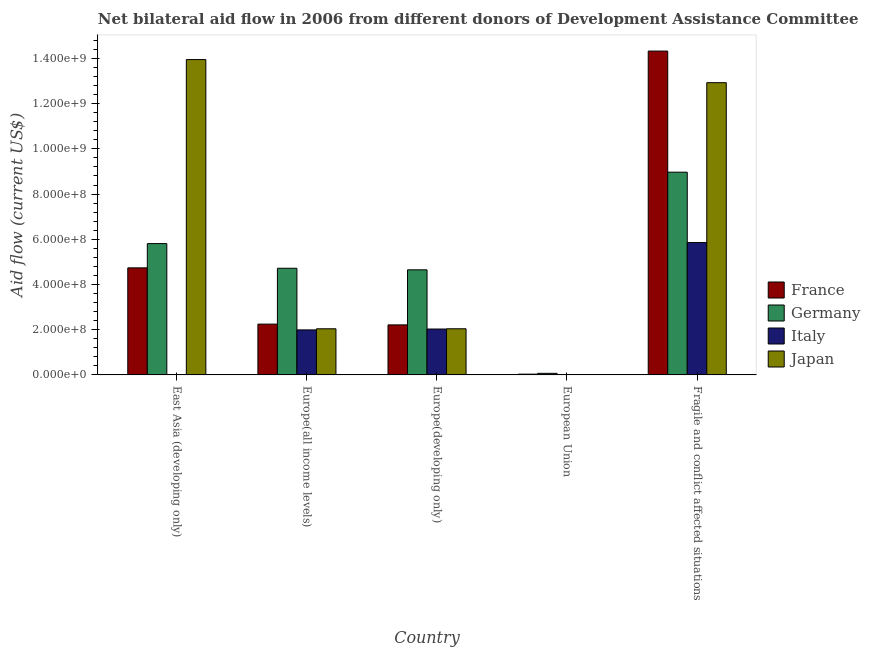How many different coloured bars are there?
Offer a very short reply. 4. How many groups of bars are there?
Offer a terse response. 5. How many bars are there on the 3rd tick from the right?
Provide a succinct answer. 4. What is the label of the 2nd group of bars from the left?
Your response must be concise. Europe(all income levels). In how many cases, is the number of bars for a given country not equal to the number of legend labels?
Offer a very short reply. 2. What is the amount of aid given by italy in Europe(all income levels)?
Keep it short and to the point. 1.99e+08. Across all countries, what is the maximum amount of aid given by germany?
Ensure brevity in your answer.  8.97e+08. Across all countries, what is the minimum amount of aid given by japan?
Offer a very short reply. 0. In which country was the amount of aid given by japan maximum?
Offer a very short reply. East Asia (developing only). What is the total amount of aid given by italy in the graph?
Give a very brief answer. 9.87e+08. What is the difference between the amount of aid given by japan in East Asia (developing only) and that in Europe(all income levels)?
Ensure brevity in your answer.  1.19e+09. What is the difference between the amount of aid given by italy in Europe(all income levels) and the amount of aid given by germany in Fragile and conflict affected situations?
Your response must be concise. -6.98e+08. What is the average amount of aid given by france per country?
Ensure brevity in your answer.  4.71e+08. What is the difference between the amount of aid given by france and amount of aid given by italy in Europe(all income levels)?
Keep it short and to the point. 2.56e+07. In how many countries, is the amount of aid given by france greater than 960000000 US$?
Keep it short and to the point. 1. What is the ratio of the amount of aid given by japan in East Asia (developing only) to that in Europe(developing only)?
Ensure brevity in your answer.  6.83. Is the amount of aid given by germany in East Asia (developing only) less than that in Europe(all income levels)?
Your answer should be very brief. No. What is the difference between the highest and the second highest amount of aid given by germany?
Keep it short and to the point. 3.16e+08. What is the difference between the highest and the lowest amount of aid given by japan?
Give a very brief answer. 1.39e+09. In how many countries, is the amount of aid given by germany greater than the average amount of aid given by germany taken over all countries?
Provide a succinct answer. 2. Is the sum of the amount of aid given by france in East Asia (developing only) and Fragile and conflict affected situations greater than the maximum amount of aid given by italy across all countries?
Give a very brief answer. Yes. Is it the case that in every country, the sum of the amount of aid given by germany and amount of aid given by japan is greater than the sum of amount of aid given by italy and amount of aid given by france?
Offer a very short reply. No. Is it the case that in every country, the sum of the amount of aid given by france and amount of aid given by germany is greater than the amount of aid given by italy?
Keep it short and to the point. Yes. How many bars are there?
Offer a very short reply. 17. What is the difference between two consecutive major ticks on the Y-axis?
Provide a succinct answer. 2.00e+08. Does the graph contain grids?
Offer a terse response. No. Where does the legend appear in the graph?
Provide a short and direct response. Center right. How are the legend labels stacked?
Ensure brevity in your answer.  Vertical. What is the title of the graph?
Keep it short and to the point. Net bilateral aid flow in 2006 from different donors of Development Assistance Committee. Does "Luxembourg" appear as one of the legend labels in the graph?
Give a very brief answer. No. What is the Aid flow (current US$) in France in East Asia (developing only)?
Provide a succinct answer. 4.74e+08. What is the Aid flow (current US$) of Germany in East Asia (developing only)?
Ensure brevity in your answer.  5.81e+08. What is the Aid flow (current US$) in Italy in East Asia (developing only)?
Your response must be concise. 0. What is the Aid flow (current US$) in Japan in East Asia (developing only)?
Offer a terse response. 1.39e+09. What is the Aid flow (current US$) in France in Europe(all income levels)?
Provide a succinct answer. 2.25e+08. What is the Aid flow (current US$) in Germany in Europe(all income levels)?
Keep it short and to the point. 4.72e+08. What is the Aid flow (current US$) of Italy in Europe(all income levels)?
Offer a very short reply. 1.99e+08. What is the Aid flow (current US$) of Japan in Europe(all income levels)?
Offer a very short reply. 2.04e+08. What is the Aid flow (current US$) of France in Europe(developing only)?
Provide a succinct answer. 2.21e+08. What is the Aid flow (current US$) in Germany in Europe(developing only)?
Provide a short and direct response. 4.65e+08. What is the Aid flow (current US$) in Italy in Europe(developing only)?
Keep it short and to the point. 2.03e+08. What is the Aid flow (current US$) in Japan in Europe(developing only)?
Give a very brief answer. 2.04e+08. What is the Aid flow (current US$) in France in European Union?
Your answer should be compact. 3.39e+06. What is the Aid flow (current US$) of Germany in European Union?
Ensure brevity in your answer.  6.94e+06. What is the Aid flow (current US$) in Japan in European Union?
Provide a short and direct response. 0. What is the Aid flow (current US$) of France in Fragile and conflict affected situations?
Offer a very short reply. 1.43e+09. What is the Aid flow (current US$) of Germany in Fragile and conflict affected situations?
Provide a succinct answer. 8.97e+08. What is the Aid flow (current US$) of Italy in Fragile and conflict affected situations?
Keep it short and to the point. 5.85e+08. What is the Aid flow (current US$) of Japan in Fragile and conflict affected situations?
Offer a terse response. 1.29e+09. Across all countries, what is the maximum Aid flow (current US$) in France?
Your answer should be compact. 1.43e+09. Across all countries, what is the maximum Aid flow (current US$) in Germany?
Your response must be concise. 8.97e+08. Across all countries, what is the maximum Aid flow (current US$) of Italy?
Your answer should be very brief. 5.85e+08. Across all countries, what is the maximum Aid flow (current US$) of Japan?
Provide a short and direct response. 1.39e+09. Across all countries, what is the minimum Aid flow (current US$) of France?
Offer a terse response. 3.39e+06. Across all countries, what is the minimum Aid flow (current US$) of Germany?
Offer a terse response. 6.94e+06. Across all countries, what is the minimum Aid flow (current US$) in Italy?
Your answer should be very brief. 0. What is the total Aid flow (current US$) in France in the graph?
Your response must be concise. 2.36e+09. What is the total Aid flow (current US$) of Germany in the graph?
Your answer should be compact. 2.42e+09. What is the total Aid flow (current US$) in Italy in the graph?
Provide a short and direct response. 9.87e+08. What is the total Aid flow (current US$) of Japan in the graph?
Offer a very short reply. 3.10e+09. What is the difference between the Aid flow (current US$) of France in East Asia (developing only) and that in Europe(all income levels)?
Provide a succinct answer. 2.49e+08. What is the difference between the Aid flow (current US$) in Germany in East Asia (developing only) and that in Europe(all income levels)?
Give a very brief answer. 1.09e+08. What is the difference between the Aid flow (current US$) in Japan in East Asia (developing only) and that in Europe(all income levels)?
Your answer should be compact. 1.19e+09. What is the difference between the Aid flow (current US$) in France in East Asia (developing only) and that in Europe(developing only)?
Ensure brevity in your answer.  2.52e+08. What is the difference between the Aid flow (current US$) of Germany in East Asia (developing only) and that in Europe(developing only)?
Ensure brevity in your answer.  1.16e+08. What is the difference between the Aid flow (current US$) of Japan in East Asia (developing only) and that in Europe(developing only)?
Offer a terse response. 1.19e+09. What is the difference between the Aid flow (current US$) in France in East Asia (developing only) and that in European Union?
Provide a succinct answer. 4.70e+08. What is the difference between the Aid flow (current US$) of Germany in East Asia (developing only) and that in European Union?
Make the answer very short. 5.74e+08. What is the difference between the Aid flow (current US$) of France in East Asia (developing only) and that in Fragile and conflict affected situations?
Your response must be concise. -9.59e+08. What is the difference between the Aid flow (current US$) of Germany in East Asia (developing only) and that in Fragile and conflict affected situations?
Provide a short and direct response. -3.16e+08. What is the difference between the Aid flow (current US$) of Japan in East Asia (developing only) and that in Fragile and conflict affected situations?
Provide a succinct answer. 1.02e+08. What is the difference between the Aid flow (current US$) in France in Europe(all income levels) and that in Europe(developing only)?
Make the answer very short. 3.39e+06. What is the difference between the Aid flow (current US$) of Germany in Europe(all income levels) and that in Europe(developing only)?
Provide a short and direct response. 6.94e+06. What is the difference between the Aid flow (current US$) in Italy in Europe(all income levels) and that in Europe(developing only)?
Keep it short and to the point. -3.89e+06. What is the difference between the Aid flow (current US$) in France in Europe(all income levels) and that in European Union?
Offer a very short reply. 2.21e+08. What is the difference between the Aid flow (current US$) of Germany in Europe(all income levels) and that in European Union?
Your answer should be compact. 4.65e+08. What is the difference between the Aid flow (current US$) in France in Europe(all income levels) and that in Fragile and conflict affected situations?
Your answer should be very brief. -1.21e+09. What is the difference between the Aid flow (current US$) in Germany in Europe(all income levels) and that in Fragile and conflict affected situations?
Your answer should be compact. -4.25e+08. What is the difference between the Aid flow (current US$) in Italy in Europe(all income levels) and that in Fragile and conflict affected situations?
Provide a succinct answer. -3.86e+08. What is the difference between the Aid flow (current US$) in Japan in Europe(all income levels) and that in Fragile and conflict affected situations?
Provide a short and direct response. -1.09e+09. What is the difference between the Aid flow (current US$) of France in Europe(developing only) and that in European Union?
Your answer should be compact. 2.18e+08. What is the difference between the Aid flow (current US$) of Germany in Europe(developing only) and that in European Union?
Keep it short and to the point. 4.58e+08. What is the difference between the Aid flow (current US$) of France in Europe(developing only) and that in Fragile and conflict affected situations?
Make the answer very short. -1.21e+09. What is the difference between the Aid flow (current US$) in Germany in Europe(developing only) and that in Fragile and conflict affected situations?
Your answer should be very brief. -4.32e+08. What is the difference between the Aid flow (current US$) of Italy in Europe(developing only) and that in Fragile and conflict affected situations?
Give a very brief answer. -3.82e+08. What is the difference between the Aid flow (current US$) in Japan in Europe(developing only) and that in Fragile and conflict affected situations?
Your response must be concise. -1.09e+09. What is the difference between the Aid flow (current US$) of France in European Union and that in Fragile and conflict affected situations?
Keep it short and to the point. -1.43e+09. What is the difference between the Aid flow (current US$) in Germany in European Union and that in Fragile and conflict affected situations?
Ensure brevity in your answer.  -8.90e+08. What is the difference between the Aid flow (current US$) in France in East Asia (developing only) and the Aid flow (current US$) in Germany in Europe(all income levels)?
Provide a short and direct response. 1.77e+06. What is the difference between the Aid flow (current US$) in France in East Asia (developing only) and the Aid flow (current US$) in Italy in Europe(all income levels)?
Give a very brief answer. 2.74e+08. What is the difference between the Aid flow (current US$) of France in East Asia (developing only) and the Aid flow (current US$) of Japan in Europe(all income levels)?
Give a very brief answer. 2.70e+08. What is the difference between the Aid flow (current US$) of Germany in East Asia (developing only) and the Aid flow (current US$) of Italy in Europe(all income levels)?
Your response must be concise. 3.82e+08. What is the difference between the Aid flow (current US$) in Germany in East Asia (developing only) and the Aid flow (current US$) in Japan in Europe(all income levels)?
Provide a succinct answer. 3.77e+08. What is the difference between the Aid flow (current US$) in France in East Asia (developing only) and the Aid flow (current US$) in Germany in Europe(developing only)?
Keep it short and to the point. 8.71e+06. What is the difference between the Aid flow (current US$) of France in East Asia (developing only) and the Aid flow (current US$) of Italy in Europe(developing only)?
Keep it short and to the point. 2.71e+08. What is the difference between the Aid flow (current US$) in France in East Asia (developing only) and the Aid flow (current US$) in Japan in Europe(developing only)?
Offer a terse response. 2.69e+08. What is the difference between the Aid flow (current US$) in Germany in East Asia (developing only) and the Aid flow (current US$) in Italy in Europe(developing only)?
Your answer should be very brief. 3.78e+08. What is the difference between the Aid flow (current US$) of Germany in East Asia (developing only) and the Aid flow (current US$) of Japan in Europe(developing only)?
Offer a terse response. 3.77e+08. What is the difference between the Aid flow (current US$) in France in East Asia (developing only) and the Aid flow (current US$) in Germany in European Union?
Your answer should be very brief. 4.67e+08. What is the difference between the Aid flow (current US$) of France in East Asia (developing only) and the Aid flow (current US$) of Germany in Fragile and conflict affected situations?
Provide a short and direct response. -4.23e+08. What is the difference between the Aid flow (current US$) of France in East Asia (developing only) and the Aid flow (current US$) of Italy in Fragile and conflict affected situations?
Give a very brief answer. -1.12e+08. What is the difference between the Aid flow (current US$) in France in East Asia (developing only) and the Aid flow (current US$) in Japan in Fragile and conflict affected situations?
Your answer should be very brief. -8.19e+08. What is the difference between the Aid flow (current US$) of Germany in East Asia (developing only) and the Aid flow (current US$) of Italy in Fragile and conflict affected situations?
Your response must be concise. -4.54e+06. What is the difference between the Aid flow (current US$) in Germany in East Asia (developing only) and the Aid flow (current US$) in Japan in Fragile and conflict affected situations?
Give a very brief answer. -7.12e+08. What is the difference between the Aid flow (current US$) of France in Europe(all income levels) and the Aid flow (current US$) of Germany in Europe(developing only)?
Provide a succinct answer. -2.40e+08. What is the difference between the Aid flow (current US$) in France in Europe(all income levels) and the Aid flow (current US$) in Italy in Europe(developing only)?
Keep it short and to the point. 2.17e+07. What is the difference between the Aid flow (current US$) of France in Europe(all income levels) and the Aid flow (current US$) of Japan in Europe(developing only)?
Give a very brief answer. 2.06e+07. What is the difference between the Aid flow (current US$) in Germany in Europe(all income levels) and the Aid flow (current US$) in Italy in Europe(developing only)?
Your answer should be compact. 2.69e+08. What is the difference between the Aid flow (current US$) of Germany in Europe(all income levels) and the Aid flow (current US$) of Japan in Europe(developing only)?
Your answer should be very brief. 2.68e+08. What is the difference between the Aid flow (current US$) of Italy in Europe(all income levels) and the Aid flow (current US$) of Japan in Europe(developing only)?
Offer a terse response. -4.98e+06. What is the difference between the Aid flow (current US$) of France in Europe(all income levels) and the Aid flow (current US$) of Germany in European Union?
Make the answer very short. 2.18e+08. What is the difference between the Aid flow (current US$) of France in Europe(all income levels) and the Aid flow (current US$) of Germany in Fragile and conflict affected situations?
Ensure brevity in your answer.  -6.72e+08. What is the difference between the Aid flow (current US$) in France in Europe(all income levels) and the Aid flow (current US$) in Italy in Fragile and conflict affected situations?
Make the answer very short. -3.61e+08. What is the difference between the Aid flow (current US$) of France in Europe(all income levels) and the Aid flow (current US$) of Japan in Fragile and conflict affected situations?
Ensure brevity in your answer.  -1.07e+09. What is the difference between the Aid flow (current US$) of Germany in Europe(all income levels) and the Aid flow (current US$) of Italy in Fragile and conflict affected situations?
Make the answer very short. -1.14e+08. What is the difference between the Aid flow (current US$) in Germany in Europe(all income levels) and the Aid flow (current US$) in Japan in Fragile and conflict affected situations?
Ensure brevity in your answer.  -8.21e+08. What is the difference between the Aid flow (current US$) of Italy in Europe(all income levels) and the Aid flow (current US$) of Japan in Fragile and conflict affected situations?
Your answer should be compact. -1.09e+09. What is the difference between the Aid flow (current US$) in France in Europe(developing only) and the Aid flow (current US$) in Germany in European Union?
Your answer should be very brief. 2.14e+08. What is the difference between the Aid flow (current US$) of France in Europe(developing only) and the Aid flow (current US$) of Germany in Fragile and conflict affected situations?
Make the answer very short. -6.75e+08. What is the difference between the Aid flow (current US$) of France in Europe(developing only) and the Aid flow (current US$) of Italy in Fragile and conflict affected situations?
Make the answer very short. -3.64e+08. What is the difference between the Aid flow (current US$) of France in Europe(developing only) and the Aid flow (current US$) of Japan in Fragile and conflict affected situations?
Make the answer very short. -1.07e+09. What is the difference between the Aid flow (current US$) of Germany in Europe(developing only) and the Aid flow (current US$) of Italy in Fragile and conflict affected situations?
Keep it short and to the point. -1.21e+08. What is the difference between the Aid flow (current US$) of Germany in Europe(developing only) and the Aid flow (current US$) of Japan in Fragile and conflict affected situations?
Provide a short and direct response. -8.28e+08. What is the difference between the Aid flow (current US$) in Italy in Europe(developing only) and the Aid flow (current US$) in Japan in Fragile and conflict affected situations?
Ensure brevity in your answer.  -1.09e+09. What is the difference between the Aid flow (current US$) of France in European Union and the Aid flow (current US$) of Germany in Fragile and conflict affected situations?
Your response must be concise. -8.93e+08. What is the difference between the Aid flow (current US$) in France in European Union and the Aid flow (current US$) in Italy in Fragile and conflict affected situations?
Provide a short and direct response. -5.82e+08. What is the difference between the Aid flow (current US$) in France in European Union and the Aid flow (current US$) in Japan in Fragile and conflict affected situations?
Ensure brevity in your answer.  -1.29e+09. What is the difference between the Aid flow (current US$) in Germany in European Union and the Aid flow (current US$) in Italy in Fragile and conflict affected situations?
Give a very brief answer. -5.78e+08. What is the difference between the Aid flow (current US$) of Germany in European Union and the Aid flow (current US$) of Japan in Fragile and conflict affected situations?
Offer a terse response. -1.29e+09. What is the average Aid flow (current US$) of France per country?
Make the answer very short. 4.71e+08. What is the average Aid flow (current US$) of Germany per country?
Provide a short and direct response. 4.84e+08. What is the average Aid flow (current US$) in Italy per country?
Offer a very short reply. 1.97e+08. What is the average Aid flow (current US$) of Japan per country?
Offer a terse response. 6.19e+08. What is the difference between the Aid flow (current US$) of France and Aid flow (current US$) of Germany in East Asia (developing only)?
Provide a short and direct response. -1.07e+08. What is the difference between the Aid flow (current US$) in France and Aid flow (current US$) in Japan in East Asia (developing only)?
Provide a succinct answer. -9.21e+08. What is the difference between the Aid flow (current US$) of Germany and Aid flow (current US$) of Japan in East Asia (developing only)?
Give a very brief answer. -8.14e+08. What is the difference between the Aid flow (current US$) of France and Aid flow (current US$) of Germany in Europe(all income levels)?
Keep it short and to the point. -2.47e+08. What is the difference between the Aid flow (current US$) in France and Aid flow (current US$) in Italy in Europe(all income levels)?
Ensure brevity in your answer.  2.56e+07. What is the difference between the Aid flow (current US$) in France and Aid flow (current US$) in Japan in Europe(all income levels)?
Your answer should be very brief. 2.06e+07. What is the difference between the Aid flow (current US$) of Germany and Aid flow (current US$) of Italy in Europe(all income levels)?
Ensure brevity in your answer.  2.73e+08. What is the difference between the Aid flow (current US$) of Germany and Aid flow (current US$) of Japan in Europe(all income levels)?
Provide a short and direct response. 2.68e+08. What is the difference between the Aid flow (current US$) of Italy and Aid flow (current US$) of Japan in Europe(all income levels)?
Ensure brevity in your answer.  -4.92e+06. What is the difference between the Aid flow (current US$) in France and Aid flow (current US$) in Germany in Europe(developing only)?
Offer a terse response. -2.44e+08. What is the difference between the Aid flow (current US$) of France and Aid flow (current US$) of Italy in Europe(developing only)?
Provide a succinct answer. 1.83e+07. What is the difference between the Aid flow (current US$) in France and Aid flow (current US$) in Japan in Europe(developing only)?
Provide a succinct answer. 1.72e+07. What is the difference between the Aid flow (current US$) of Germany and Aid flow (current US$) of Italy in Europe(developing only)?
Provide a succinct answer. 2.62e+08. What is the difference between the Aid flow (current US$) of Germany and Aid flow (current US$) of Japan in Europe(developing only)?
Your response must be concise. 2.61e+08. What is the difference between the Aid flow (current US$) in Italy and Aid flow (current US$) in Japan in Europe(developing only)?
Offer a terse response. -1.09e+06. What is the difference between the Aid flow (current US$) of France and Aid flow (current US$) of Germany in European Union?
Give a very brief answer. -3.55e+06. What is the difference between the Aid flow (current US$) in France and Aid flow (current US$) in Germany in Fragile and conflict affected situations?
Offer a terse response. 5.36e+08. What is the difference between the Aid flow (current US$) of France and Aid flow (current US$) of Italy in Fragile and conflict affected situations?
Provide a succinct answer. 8.47e+08. What is the difference between the Aid flow (current US$) in France and Aid flow (current US$) in Japan in Fragile and conflict affected situations?
Ensure brevity in your answer.  1.40e+08. What is the difference between the Aid flow (current US$) of Germany and Aid flow (current US$) of Italy in Fragile and conflict affected situations?
Provide a succinct answer. 3.11e+08. What is the difference between the Aid flow (current US$) of Germany and Aid flow (current US$) of Japan in Fragile and conflict affected situations?
Your response must be concise. -3.96e+08. What is the difference between the Aid flow (current US$) in Italy and Aid flow (current US$) in Japan in Fragile and conflict affected situations?
Offer a terse response. -7.07e+08. What is the ratio of the Aid flow (current US$) in France in East Asia (developing only) to that in Europe(all income levels)?
Your answer should be very brief. 2.11. What is the ratio of the Aid flow (current US$) of Germany in East Asia (developing only) to that in Europe(all income levels)?
Keep it short and to the point. 1.23. What is the ratio of the Aid flow (current US$) in Japan in East Asia (developing only) to that in Europe(all income levels)?
Offer a terse response. 6.84. What is the ratio of the Aid flow (current US$) of France in East Asia (developing only) to that in Europe(developing only)?
Give a very brief answer. 2.14. What is the ratio of the Aid flow (current US$) of Germany in East Asia (developing only) to that in Europe(developing only)?
Keep it short and to the point. 1.25. What is the ratio of the Aid flow (current US$) of Japan in East Asia (developing only) to that in Europe(developing only)?
Make the answer very short. 6.83. What is the ratio of the Aid flow (current US$) in France in East Asia (developing only) to that in European Union?
Offer a terse response. 139.68. What is the ratio of the Aid flow (current US$) of Germany in East Asia (developing only) to that in European Union?
Provide a succinct answer. 83.69. What is the ratio of the Aid flow (current US$) of France in East Asia (developing only) to that in Fragile and conflict affected situations?
Keep it short and to the point. 0.33. What is the ratio of the Aid flow (current US$) of Germany in East Asia (developing only) to that in Fragile and conflict affected situations?
Offer a terse response. 0.65. What is the ratio of the Aid flow (current US$) of Japan in East Asia (developing only) to that in Fragile and conflict affected situations?
Make the answer very short. 1.08. What is the ratio of the Aid flow (current US$) of France in Europe(all income levels) to that in Europe(developing only)?
Provide a short and direct response. 1.02. What is the ratio of the Aid flow (current US$) of Germany in Europe(all income levels) to that in Europe(developing only)?
Provide a short and direct response. 1.01. What is the ratio of the Aid flow (current US$) in Italy in Europe(all income levels) to that in Europe(developing only)?
Your answer should be very brief. 0.98. What is the ratio of the Aid flow (current US$) of Japan in Europe(all income levels) to that in Europe(developing only)?
Give a very brief answer. 1. What is the ratio of the Aid flow (current US$) of France in Europe(all income levels) to that in European Union?
Give a very brief answer. 66.28. What is the ratio of the Aid flow (current US$) of Germany in Europe(all income levels) to that in European Union?
Keep it short and to the point. 67.98. What is the ratio of the Aid flow (current US$) of France in Europe(all income levels) to that in Fragile and conflict affected situations?
Offer a terse response. 0.16. What is the ratio of the Aid flow (current US$) of Germany in Europe(all income levels) to that in Fragile and conflict affected situations?
Give a very brief answer. 0.53. What is the ratio of the Aid flow (current US$) in Italy in Europe(all income levels) to that in Fragile and conflict affected situations?
Your answer should be compact. 0.34. What is the ratio of the Aid flow (current US$) of Japan in Europe(all income levels) to that in Fragile and conflict affected situations?
Provide a short and direct response. 0.16. What is the ratio of the Aid flow (current US$) of France in Europe(developing only) to that in European Union?
Your response must be concise. 65.28. What is the ratio of the Aid flow (current US$) of Germany in Europe(developing only) to that in European Union?
Give a very brief answer. 66.98. What is the ratio of the Aid flow (current US$) in France in Europe(developing only) to that in Fragile and conflict affected situations?
Your answer should be compact. 0.15. What is the ratio of the Aid flow (current US$) of Germany in Europe(developing only) to that in Fragile and conflict affected situations?
Your response must be concise. 0.52. What is the ratio of the Aid flow (current US$) of Italy in Europe(developing only) to that in Fragile and conflict affected situations?
Your response must be concise. 0.35. What is the ratio of the Aid flow (current US$) of Japan in Europe(developing only) to that in Fragile and conflict affected situations?
Offer a very short reply. 0.16. What is the ratio of the Aid flow (current US$) in France in European Union to that in Fragile and conflict affected situations?
Offer a very short reply. 0. What is the ratio of the Aid flow (current US$) in Germany in European Union to that in Fragile and conflict affected situations?
Your response must be concise. 0.01. What is the difference between the highest and the second highest Aid flow (current US$) of France?
Give a very brief answer. 9.59e+08. What is the difference between the highest and the second highest Aid flow (current US$) of Germany?
Your answer should be very brief. 3.16e+08. What is the difference between the highest and the second highest Aid flow (current US$) of Italy?
Provide a succinct answer. 3.82e+08. What is the difference between the highest and the second highest Aid flow (current US$) in Japan?
Provide a short and direct response. 1.02e+08. What is the difference between the highest and the lowest Aid flow (current US$) of France?
Give a very brief answer. 1.43e+09. What is the difference between the highest and the lowest Aid flow (current US$) of Germany?
Keep it short and to the point. 8.90e+08. What is the difference between the highest and the lowest Aid flow (current US$) of Italy?
Your response must be concise. 5.85e+08. What is the difference between the highest and the lowest Aid flow (current US$) in Japan?
Your answer should be compact. 1.39e+09. 